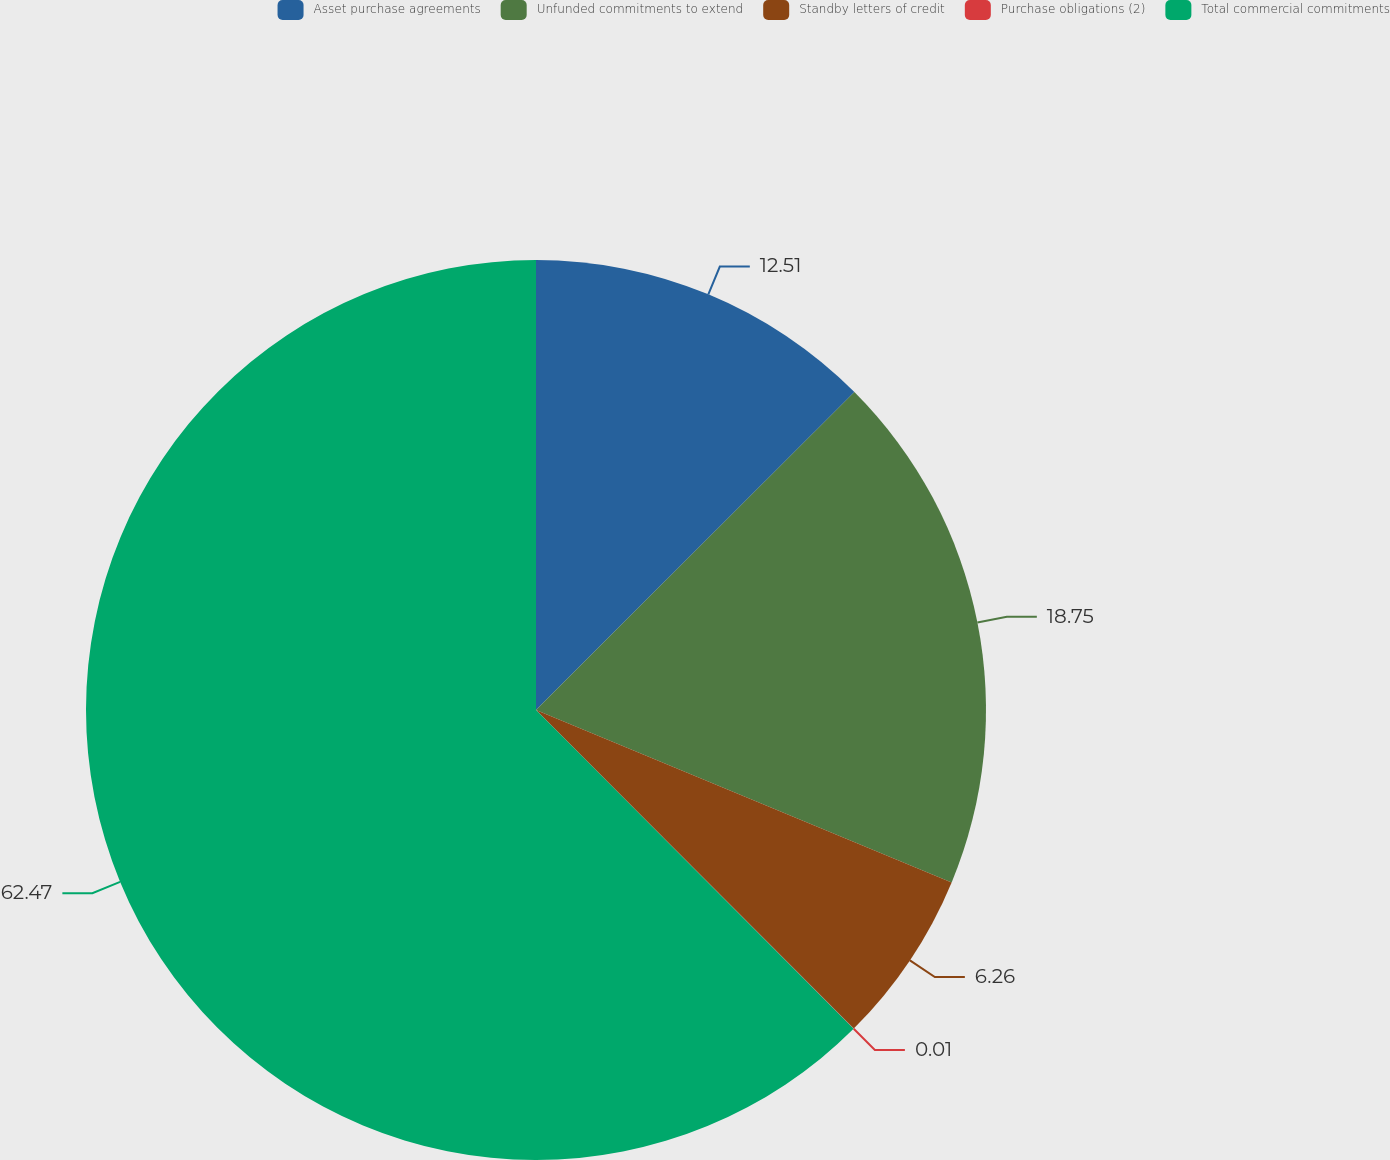Convert chart to OTSL. <chart><loc_0><loc_0><loc_500><loc_500><pie_chart><fcel>Asset purchase agreements<fcel>Unfunded commitments to extend<fcel>Standby letters of credit<fcel>Purchase obligations (2)<fcel>Total commercial commitments<nl><fcel>12.51%<fcel>18.75%<fcel>6.26%<fcel>0.01%<fcel>62.47%<nl></chart> 